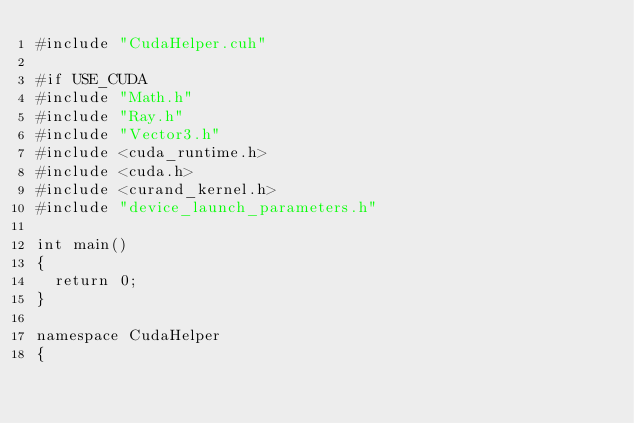<code> <loc_0><loc_0><loc_500><loc_500><_Cuda_>#include "CudaHelper.cuh"

#if USE_CUDA
#include "Math.h"
#include "Ray.h"
#include "Vector3.h"
#include <cuda_runtime.h>
#include <cuda.h>
#include <curand_kernel.h>
#include "device_launch_parameters.h"

int main()
{
	return 0;
}

namespace CudaHelper
{</code> 